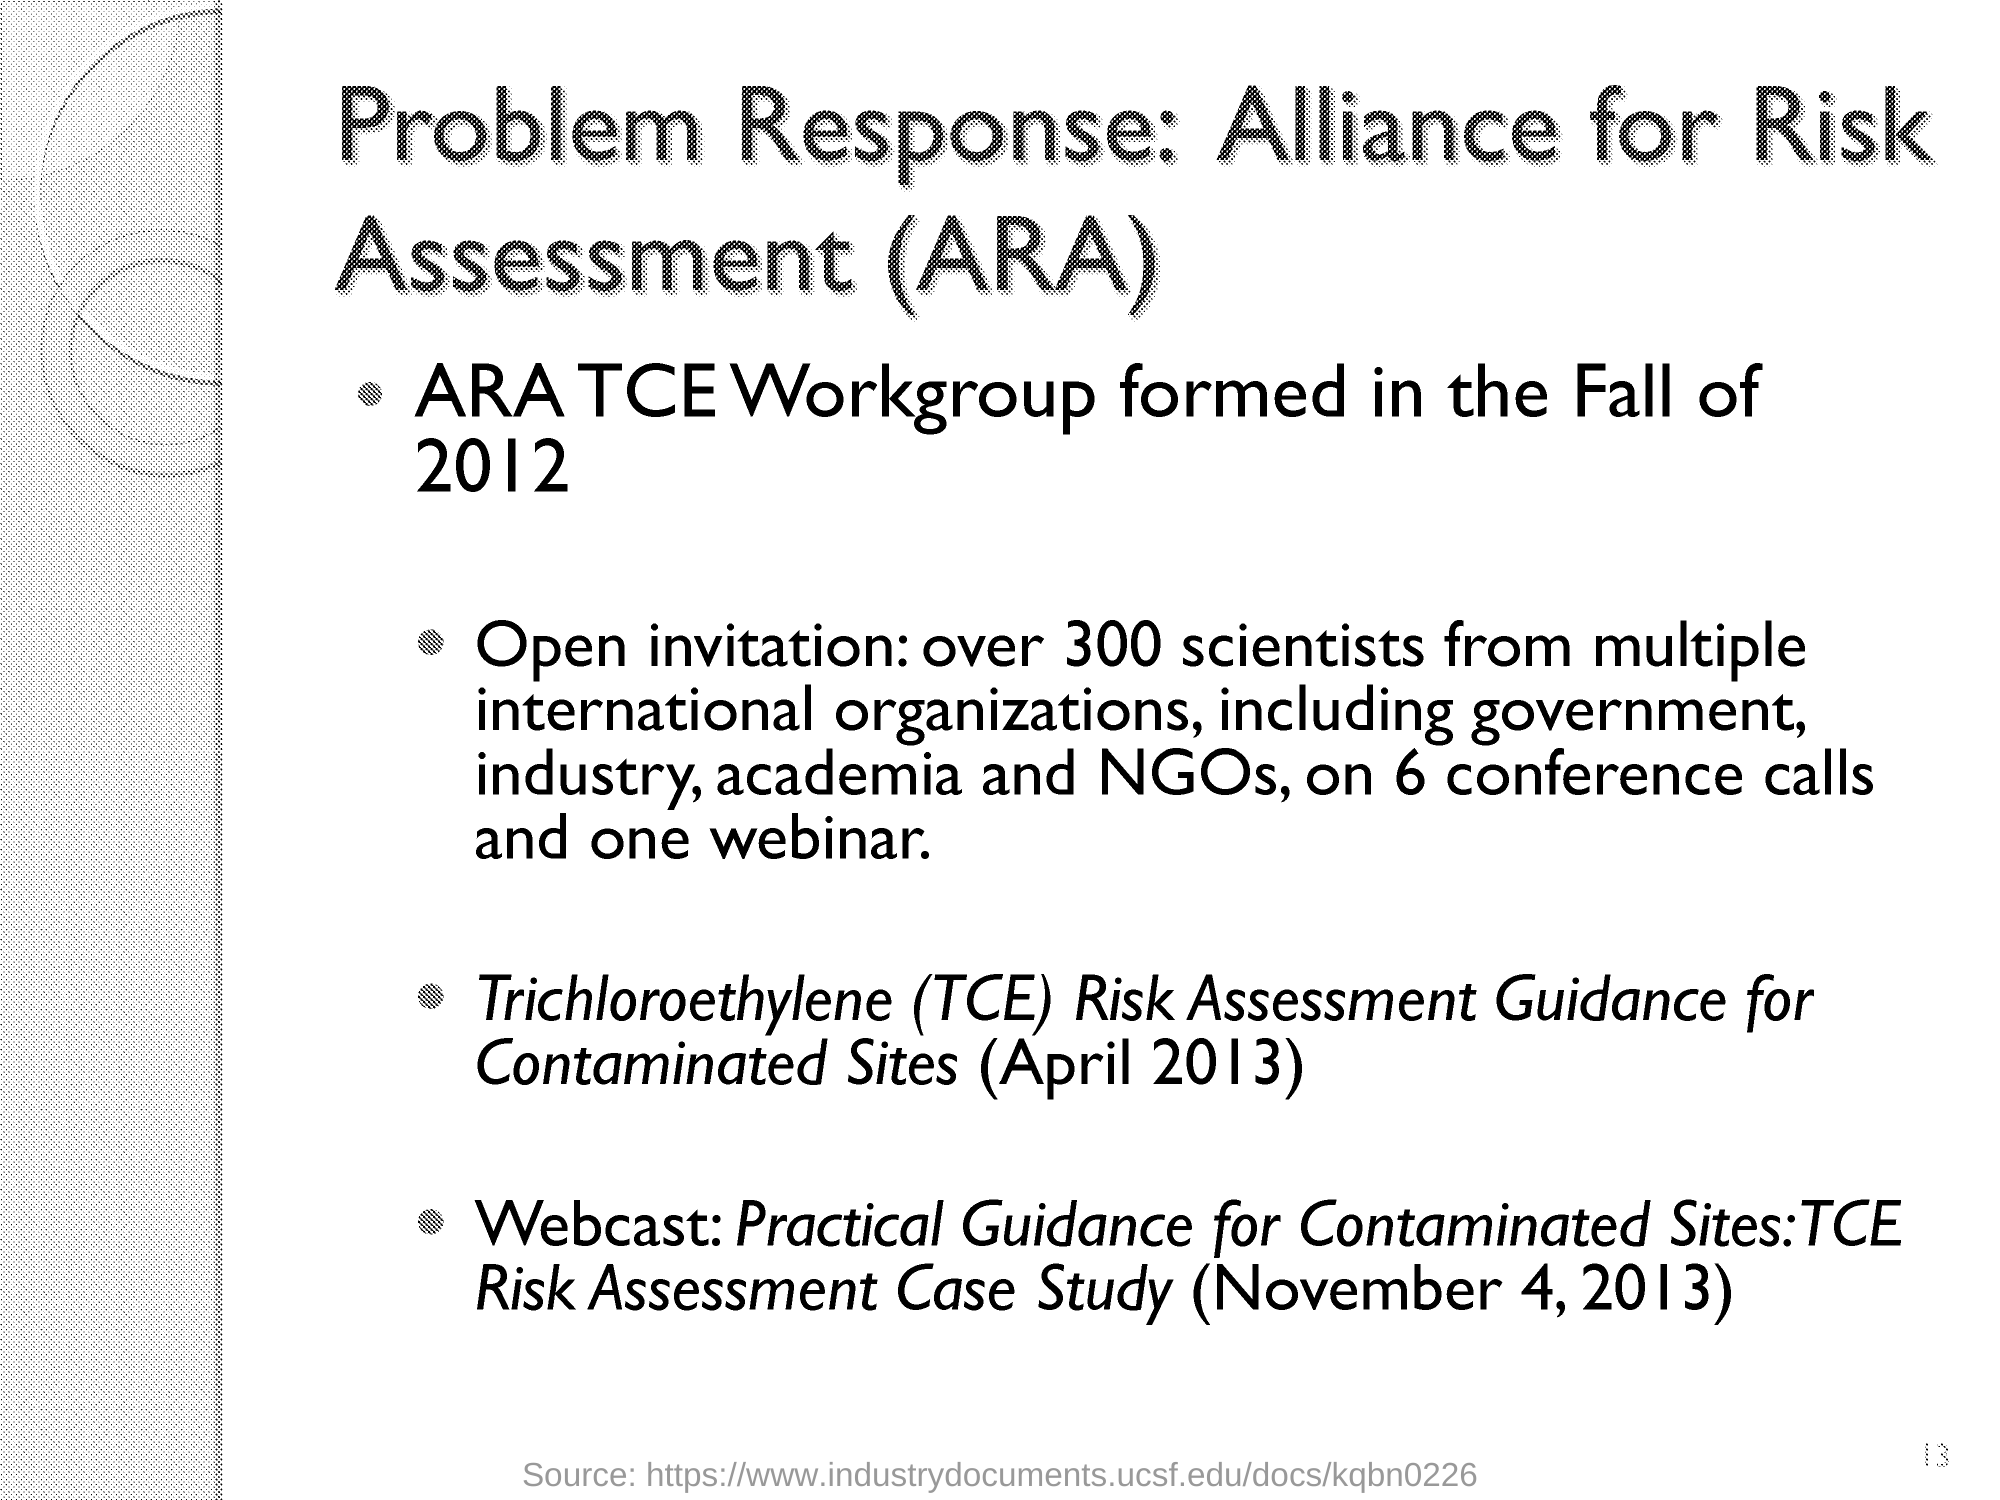Identify some key points in this picture. Alliance for Risk Assessment, abbreviated as ARA, is a coalition of organizations dedicated to advancing the field of risk assessment through research and collaboration. Over 300 scientists from multiple international organizations have been invited. The ARA TCE Workgroup was formed in the Fall of 2012. Trichloroethylene (TCE) is a chemical compound whose full form is Trichloroethylene. It is a chlorinated hydrocarbon that is used as an industrial solvent and as a metal cleaning agent. TCE has been identified as a potential human carcinogen and is considered a groundwater contaminant due to its ability to dissolve and transport other contaminants in soil and groundwater. 